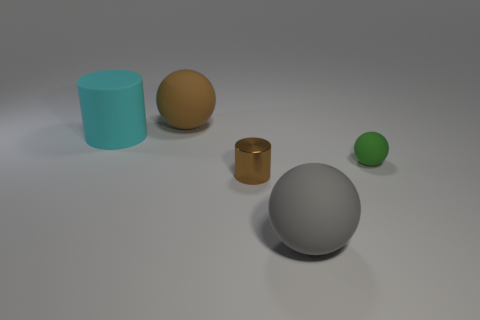Subtract 1 balls. How many balls are left? 2 Add 2 tiny yellow matte cylinders. How many objects exist? 7 Subtract all cylinders. How many objects are left? 3 Add 1 tiny shiny things. How many tiny shiny things exist? 2 Subtract 0 gray blocks. How many objects are left? 5 Subtract all tiny brown cylinders. Subtract all tiny metallic things. How many objects are left? 3 Add 2 brown cylinders. How many brown cylinders are left? 3 